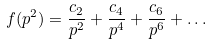Convert formula to latex. <formula><loc_0><loc_0><loc_500><loc_500>f ( p ^ { 2 } ) = \frac { c _ { 2 } } { p ^ { 2 } } + \frac { c _ { 4 } } { p ^ { 4 } } + \frac { c _ { 6 } } { p ^ { 6 } } + \dots</formula> 